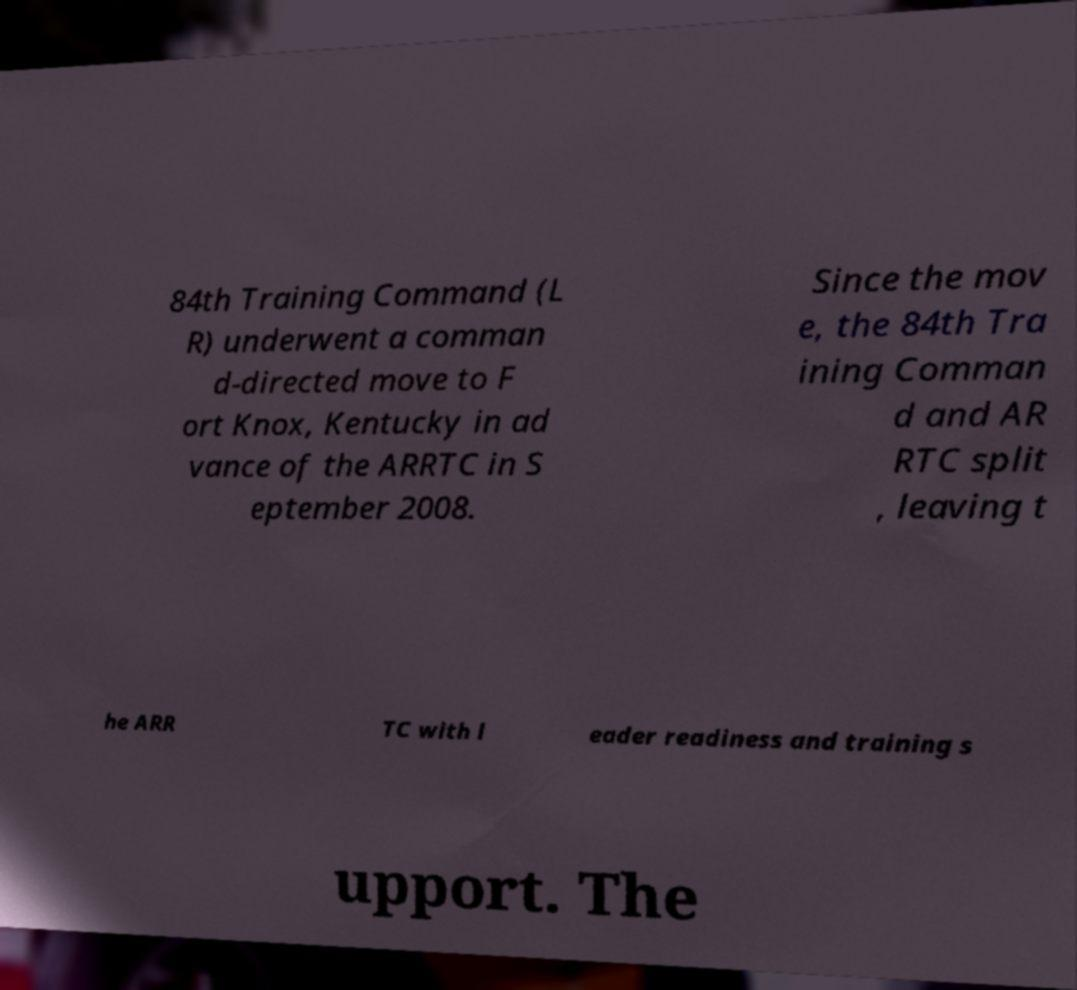For documentation purposes, I need the text within this image transcribed. Could you provide that? 84th Training Command (L R) underwent a comman d-directed move to F ort Knox, Kentucky in ad vance of the ARRTC in S eptember 2008. Since the mov e, the 84th Tra ining Comman d and AR RTC split , leaving t he ARR TC with l eader readiness and training s upport. The 